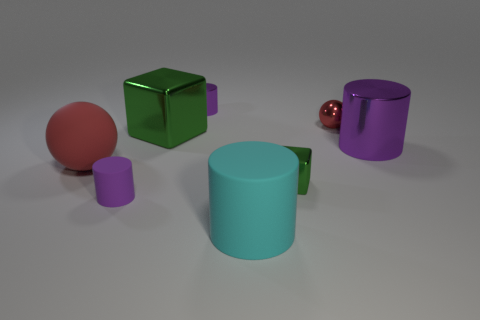How many purple cylinders must be subtracted to get 1 purple cylinders? 2 Subtract all green cubes. How many purple cylinders are left? 3 Add 1 purple cubes. How many objects exist? 9 Subtract all spheres. How many objects are left? 6 Add 7 small red metallic balls. How many small red metallic balls are left? 8 Add 6 small green metallic objects. How many small green metallic objects exist? 7 Subtract 0 yellow blocks. How many objects are left? 8 Subtract all large blue matte objects. Subtract all small purple things. How many objects are left? 6 